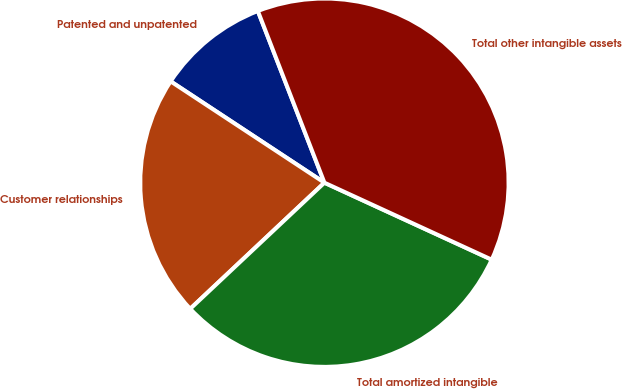Convert chart. <chart><loc_0><loc_0><loc_500><loc_500><pie_chart><fcel>Patented and unpatented<fcel>Customer relationships<fcel>Total amortized intangible<fcel>Total other intangible assets<nl><fcel>9.84%<fcel>21.28%<fcel>31.13%<fcel>37.75%<nl></chart> 